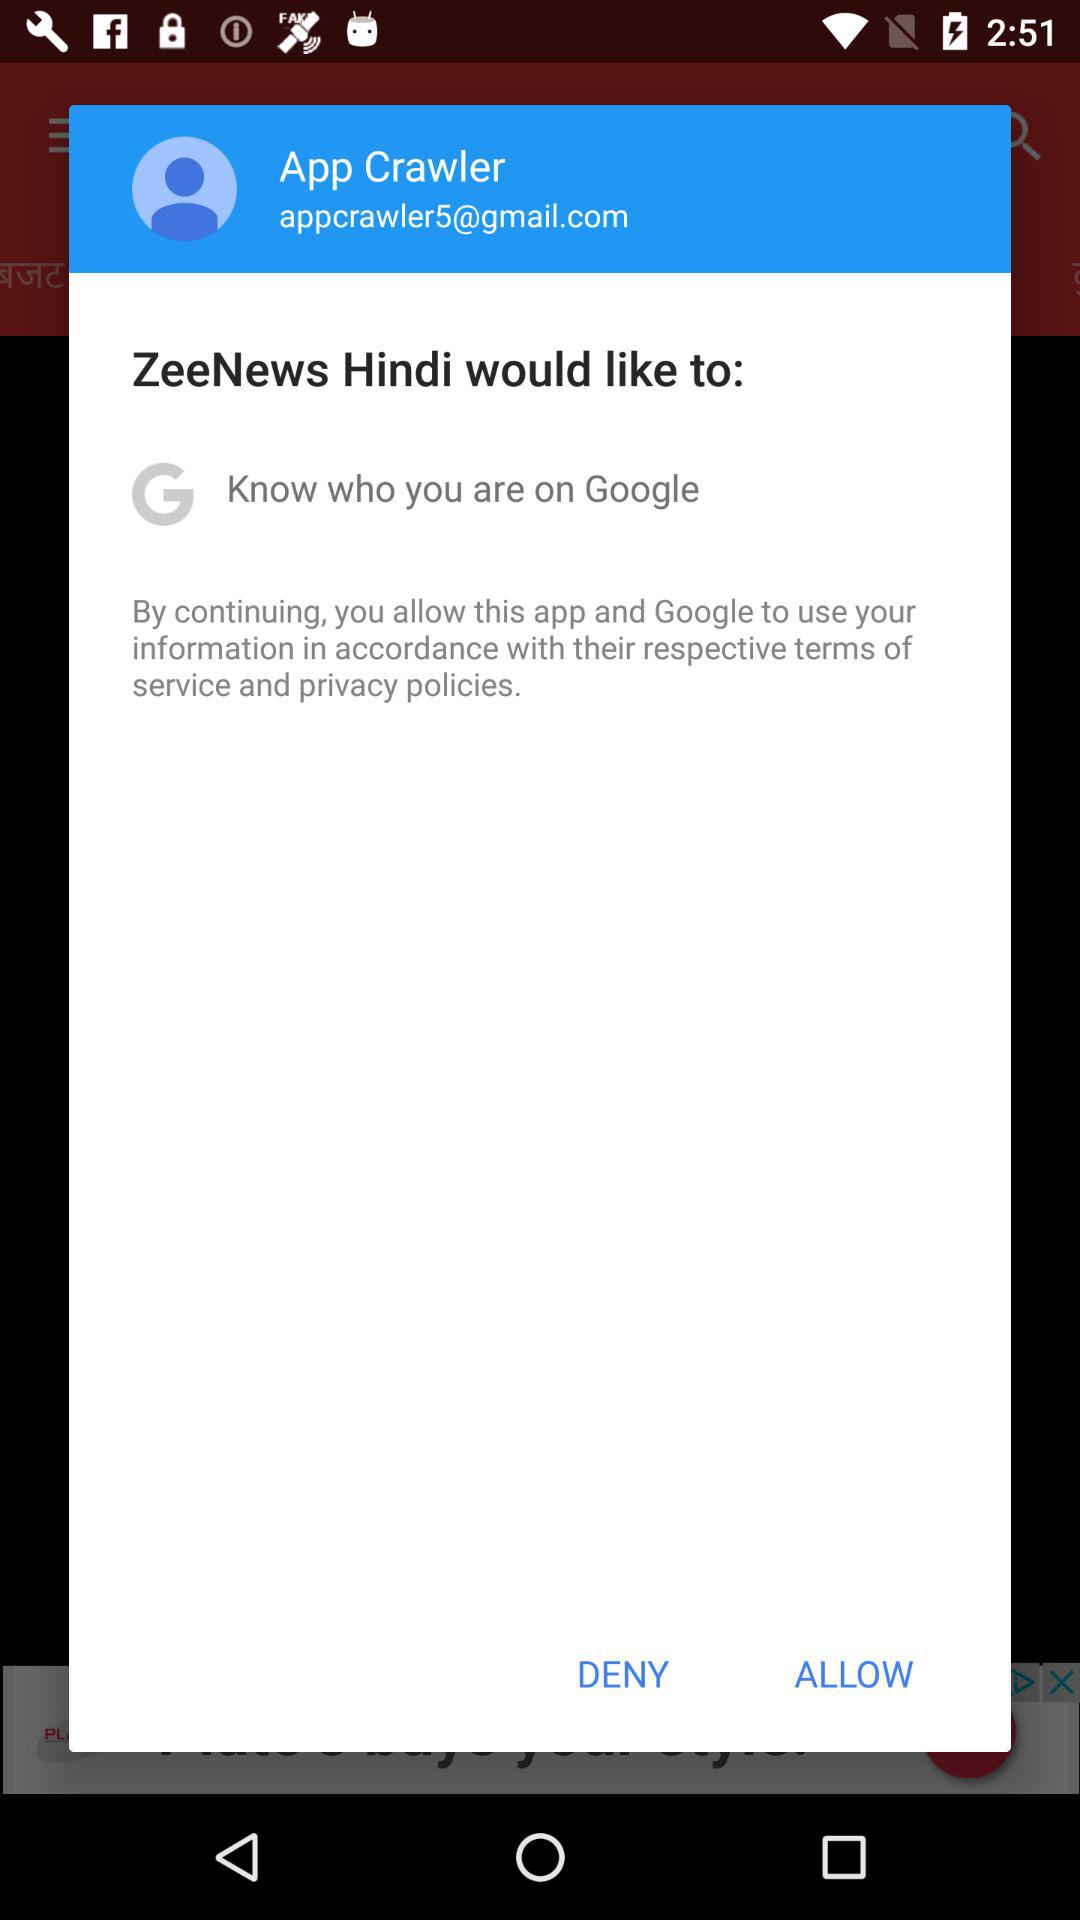What is the email address? The email address is appcrawler5@gmail.com. 